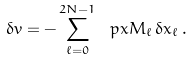Convert formula to latex. <formula><loc_0><loc_0><loc_500><loc_500>\delta v = - \sum _ { \ell = 0 } ^ { 2 N - 1 } \ p x M _ { \ell } \, \delta x _ { \ell } \, .</formula> 